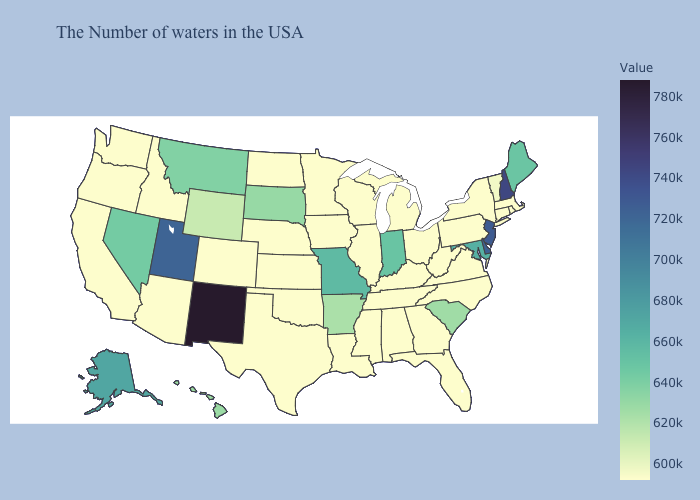Does Maine have the lowest value in the Northeast?
Keep it brief. No. Does Alabama have a higher value than Nevada?
Answer briefly. No. Among the states that border Oklahoma , which have the highest value?
Short answer required. New Mexico. Among the states that border Arkansas , does Missouri have the lowest value?
Be succinct. No. Among the states that border Texas , does Louisiana have the lowest value?
Be succinct. Yes. Which states hav the highest value in the MidWest?
Answer briefly. Missouri. Which states have the lowest value in the USA?
Short answer required. Massachusetts, Rhode Island, Connecticut, New York, Pennsylvania, Virginia, North Carolina, West Virginia, Ohio, Florida, Georgia, Michigan, Kentucky, Alabama, Tennessee, Wisconsin, Illinois, Mississippi, Louisiana, Minnesota, Iowa, Kansas, Nebraska, Oklahoma, Texas, North Dakota, Colorado, Arizona, Idaho, California, Washington, Oregon. Does the map have missing data?
Answer briefly. No. 